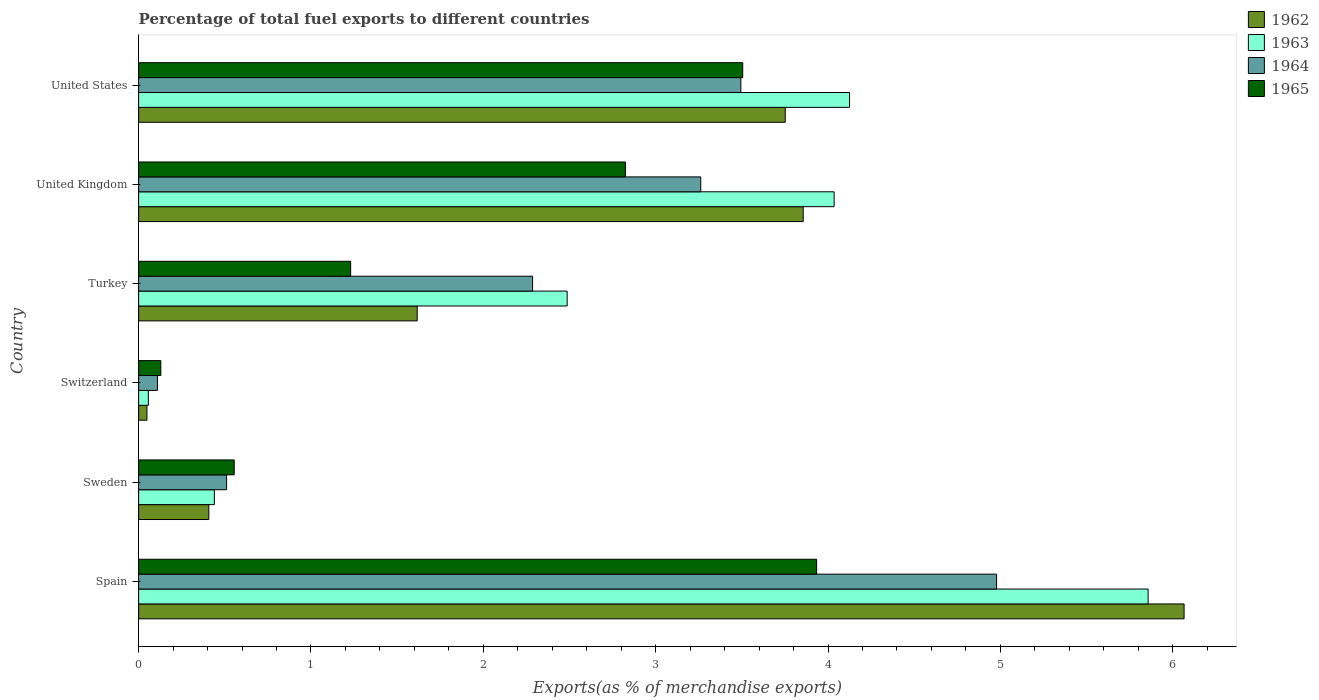Are the number of bars per tick equal to the number of legend labels?
Your answer should be very brief. Yes. How many bars are there on the 5th tick from the top?
Provide a succinct answer. 4. What is the label of the 6th group of bars from the top?
Offer a very short reply. Spain. What is the percentage of exports to different countries in 1963 in United States?
Ensure brevity in your answer.  4.13. Across all countries, what is the maximum percentage of exports to different countries in 1962?
Offer a terse response. 6.07. Across all countries, what is the minimum percentage of exports to different countries in 1962?
Offer a very short reply. 0.05. In which country was the percentage of exports to different countries in 1965 maximum?
Offer a terse response. Spain. In which country was the percentage of exports to different countries in 1962 minimum?
Offer a very short reply. Switzerland. What is the total percentage of exports to different countries in 1965 in the graph?
Your response must be concise. 12.18. What is the difference between the percentage of exports to different countries in 1963 in Sweden and that in Switzerland?
Offer a terse response. 0.38. What is the difference between the percentage of exports to different countries in 1964 in United States and the percentage of exports to different countries in 1965 in Turkey?
Ensure brevity in your answer.  2.26. What is the average percentage of exports to different countries in 1963 per country?
Your answer should be compact. 2.83. What is the difference between the percentage of exports to different countries in 1963 and percentage of exports to different countries in 1964 in Sweden?
Your response must be concise. -0.07. In how many countries, is the percentage of exports to different countries in 1965 greater than 1.6 %?
Give a very brief answer. 3. What is the ratio of the percentage of exports to different countries in 1963 in Spain to that in United States?
Ensure brevity in your answer.  1.42. Is the percentage of exports to different countries in 1965 in Switzerland less than that in United Kingdom?
Offer a terse response. Yes. Is the difference between the percentage of exports to different countries in 1963 in Turkey and United Kingdom greater than the difference between the percentage of exports to different countries in 1964 in Turkey and United Kingdom?
Your answer should be compact. No. What is the difference between the highest and the second highest percentage of exports to different countries in 1963?
Provide a short and direct response. 1.73. What is the difference between the highest and the lowest percentage of exports to different countries in 1963?
Make the answer very short. 5.8. Is it the case that in every country, the sum of the percentage of exports to different countries in 1963 and percentage of exports to different countries in 1962 is greater than the sum of percentage of exports to different countries in 1965 and percentage of exports to different countries in 1964?
Offer a very short reply. No. What does the 1st bar from the top in Turkey represents?
Provide a short and direct response. 1965. What does the 3rd bar from the bottom in Switzerland represents?
Provide a short and direct response. 1964. How many bars are there?
Keep it short and to the point. 24. Are all the bars in the graph horizontal?
Offer a terse response. Yes. How many countries are there in the graph?
Keep it short and to the point. 6. Does the graph contain any zero values?
Offer a very short reply. No. How many legend labels are there?
Provide a succinct answer. 4. What is the title of the graph?
Provide a succinct answer. Percentage of total fuel exports to different countries. What is the label or title of the X-axis?
Keep it short and to the point. Exports(as % of merchandise exports). What is the Exports(as % of merchandise exports) of 1962 in Spain?
Offer a terse response. 6.07. What is the Exports(as % of merchandise exports) of 1963 in Spain?
Provide a short and direct response. 5.86. What is the Exports(as % of merchandise exports) in 1964 in Spain?
Offer a terse response. 4.98. What is the Exports(as % of merchandise exports) of 1965 in Spain?
Provide a succinct answer. 3.93. What is the Exports(as % of merchandise exports) of 1962 in Sweden?
Your response must be concise. 0.41. What is the Exports(as % of merchandise exports) in 1963 in Sweden?
Ensure brevity in your answer.  0.44. What is the Exports(as % of merchandise exports) in 1964 in Sweden?
Provide a short and direct response. 0.51. What is the Exports(as % of merchandise exports) of 1965 in Sweden?
Ensure brevity in your answer.  0.55. What is the Exports(as % of merchandise exports) in 1962 in Switzerland?
Provide a short and direct response. 0.05. What is the Exports(as % of merchandise exports) of 1963 in Switzerland?
Offer a very short reply. 0.06. What is the Exports(as % of merchandise exports) in 1964 in Switzerland?
Your answer should be compact. 0.11. What is the Exports(as % of merchandise exports) of 1965 in Switzerland?
Keep it short and to the point. 0.13. What is the Exports(as % of merchandise exports) in 1962 in Turkey?
Your response must be concise. 1.62. What is the Exports(as % of merchandise exports) in 1963 in Turkey?
Offer a very short reply. 2.49. What is the Exports(as % of merchandise exports) of 1964 in Turkey?
Your response must be concise. 2.29. What is the Exports(as % of merchandise exports) of 1965 in Turkey?
Make the answer very short. 1.23. What is the Exports(as % of merchandise exports) in 1962 in United Kingdom?
Provide a short and direct response. 3.86. What is the Exports(as % of merchandise exports) of 1963 in United Kingdom?
Provide a short and direct response. 4.04. What is the Exports(as % of merchandise exports) in 1964 in United Kingdom?
Your response must be concise. 3.26. What is the Exports(as % of merchandise exports) of 1965 in United Kingdom?
Provide a short and direct response. 2.82. What is the Exports(as % of merchandise exports) in 1962 in United States?
Provide a short and direct response. 3.75. What is the Exports(as % of merchandise exports) in 1963 in United States?
Offer a terse response. 4.13. What is the Exports(as % of merchandise exports) in 1964 in United States?
Provide a succinct answer. 3.49. What is the Exports(as % of merchandise exports) of 1965 in United States?
Your answer should be compact. 3.51. Across all countries, what is the maximum Exports(as % of merchandise exports) of 1962?
Your answer should be compact. 6.07. Across all countries, what is the maximum Exports(as % of merchandise exports) in 1963?
Your answer should be very brief. 5.86. Across all countries, what is the maximum Exports(as % of merchandise exports) in 1964?
Offer a very short reply. 4.98. Across all countries, what is the maximum Exports(as % of merchandise exports) of 1965?
Offer a very short reply. 3.93. Across all countries, what is the minimum Exports(as % of merchandise exports) in 1962?
Your response must be concise. 0.05. Across all countries, what is the minimum Exports(as % of merchandise exports) in 1963?
Provide a succinct answer. 0.06. Across all countries, what is the minimum Exports(as % of merchandise exports) of 1964?
Make the answer very short. 0.11. Across all countries, what is the minimum Exports(as % of merchandise exports) in 1965?
Your answer should be very brief. 0.13. What is the total Exports(as % of merchandise exports) in 1962 in the graph?
Keep it short and to the point. 15.75. What is the total Exports(as % of merchandise exports) of 1963 in the graph?
Keep it short and to the point. 17. What is the total Exports(as % of merchandise exports) of 1964 in the graph?
Provide a succinct answer. 14.64. What is the total Exports(as % of merchandise exports) of 1965 in the graph?
Provide a succinct answer. 12.18. What is the difference between the Exports(as % of merchandise exports) of 1962 in Spain and that in Sweden?
Offer a terse response. 5.66. What is the difference between the Exports(as % of merchandise exports) in 1963 in Spain and that in Sweden?
Your response must be concise. 5.42. What is the difference between the Exports(as % of merchandise exports) in 1964 in Spain and that in Sweden?
Offer a very short reply. 4.47. What is the difference between the Exports(as % of merchandise exports) of 1965 in Spain and that in Sweden?
Ensure brevity in your answer.  3.38. What is the difference between the Exports(as % of merchandise exports) of 1962 in Spain and that in Switzerland?
Give a very brief answer. 6.02. What is the difference between the Exports(as % of merchandise exports) in 1963 in Spain and that in Switzerland?
Your response must be concise. 5.8. What is the difference between the Exports(as % of merchandise exports) of 1964 in Spain and that in Switzerland?
Provide a succinct answer. 4.87. What is the difference between the Exports(as % of merchandise exports) of 1965 in Spain and that in Switzerland?
Make the answer very short. 3.81. What is the difference between the Exports(as % of merchandise exports) of 1962 in Spain and that in Turkey?
Your answer should be compact. 4.45. What is the difference between the Exports(as % of merchandise exports) of 1963 in Spain and that in Turkey?
Give a very brief answer. 3.37. What is the difference between the Exports(as % of merchandise exports) of 1964 in Spain and that in Turkey?
Provide a short and direct response. 2.69. What is the difference between the Exports(as % of merchandise exports) of 1965 in Spain and that in Turkey?
Provide a short and direct response. 2.7. What is the difference between the Exports(as % of merchandise exports) of 1962 in Spain and that in United Kingdom?
Give a very brief answer. 2.21. What is the difference between the Exports(as % of merchandise exports) in 1963 in Spain and that in United Kingdom?
Make the answer very short. 1.82. What is the difference between the Exports(as % of merchandise exports) in 1964 in Spain and that in United Kingdom?
Keep it short and to the point. 1.72. What is the difference between the Exports(as % of merchandise exports) of 1965 in Spain and that in United Kingdom?
Provide a short and direct response. 1.11. What is the difference between the Exports(as % of merchandise exports) of 1962 in Spain and that in United States?
Keep it short and to the point. 2.31. What is the difference between the Exports(as % of merchandise exports) of 1963 in Spain and that in United States?
Your answer should be compact. 1.73. What is the difference between the Exports(as % of merchandise exports) of 1964 in Spain and that in United States?
Provide a succinct answer. 1.48. What is the difference between the Exports(as % of merchandise exports) of 1965 in Spain and that in United States?
Your response must be concise. 0.43. What is the difference between the Exports(as % of merchandise exports) of 1962 in Sweden and that in Switzerland?
Offer a very short reply. 0.36. What is the difference between the Exports(as % of merchandise exports) of 1963 in Sweden and that in Switzerland?
Provide a succinct answer. 0.38. What is the difference between the Exports(as % of merchandise exports) of 1964 in Sweden and that in Switzerland?
Give a very brief answer. 0.4. What is the difference between the Exports(as % of merchandise exports) in 1965 in Sweden and that in Switzerland?
Provide a short and direct response. 0.43. What is the difference between the Exports(as % of merchandise exports) of 1962 in Sweden and that in Turkey?
Your answer should be compact. -1.21. What is the difference between the Exports(as % of merchandise exports) in 1963 in Sweden and that in Turkey?
Make the answer very short. -2.05. What is the difference between the Exports(as % of merchandise exports) in 1964 in Sweden and that in Turkey?
Provide a short and direct response. -1.78. What is the difference between the Exports(as % of merchandise exports) in 1965 in Sweden and that in Turkey?
Keep it short and to the point. -0.68. What is the difference between the Exports(as % of merchandise exports) in 1962 in Sweden and that in United Kingdom?
Provide a short and direct response. -3.45. What is the difference between the Exports(as % of merchandise exports) in 1963 in Sweden and that in United Kingdom?
Your answer should be compact. -3.6. What is the difference between the Exports(as % of merchandise exports) in 1964 in Sweden and that in United Kingdom?
Your answer should be compact. -2.75. What is the difference between the Exports(as % of merchandise exports) in 1965 in Sweden and that in United Kingdom?
Make the answer very short. -2.27. What is the difference between the Exports(as % of merchandise exports) of 1962 in Sweden and that in United States?
Make the answer very short. -3.34. What is the difference between the Exports(as % of merchandise exports) in 1963 in Sweden and that in United States?
Give a very brief answer. -3.69. What is the difference between the Exports(as % of merchandise exports) in 1964 in Sweden and that in United States?
Provide a succinct answer. -2.98. What is the difference between the Exports(as % of merchandise exports) of 1965 in Sweden and that in United States?
Offer a very short reply. -2.95. What is the difference between the Exports(as % of merchandise exports) in 1962 in Switzerland and that in Turkey?
Provide a short and direct response. -1.57. What is the difference between the Exports(as % of merchandise exports) in 1963 in Switzerland and that in Turkey?
Ensure brevity in your answer.  -2.43. What is the difference between the Exports(as % of merchandise exports) in 1964 in Switzerland and that in Turkey?
Ensure brevity in your answer.  -2.18. What is the difference between the Exports(as % of merchandise exports) in 1965 in Switzerland and that in Turkey?
Ensure brevity in your answer.  -1.1. What is the difference between the Exports(as % of merchandise exports) of 1962 in Switzerland and that in United Kingdom?
Give a very brief answer. -3.81. What is the difference between the Exports(as % of merchandise exports) of 1963 in Switzerland and that in United Kingdom?
Your answer should be compact. -3.98. What is the difference between the Exports(as % of merchandise exports) in 1964 in Switzerland and that in United Kingdom?
Keep it short and to the point. -3.15. What is the difference between the Exports(as % of merchandise exports) of 1965 in Switzerland and that in United Kingdom?
Your answer should be very brief. -2.7. What is the difference between the Exports(as % of merchandise exports) of 1962 in Switzerland and that in United States?
Provide a short and direct response. -3.7. What is the difference between the Exports(as % of merchandise exports) of 1963 in Switzerland and that in United States?
Offer a very short reply. -4.07. What is the difference between the Exports(as % of merchandise exports) of 1964 in Switzerland and that in United States?
Offer a very short reply. -3.39. What is the difference between the Exports(as % of merchandise exports) of 1965 in Switzerland and that in United States?
Ensure brevity in your answer.  -3.38. What is the difference between the Exports(as % of merchandise exports) of 1962 in Turkey and that in United Kingdom?
Offer a very short reply. -2.24. What is the difference between the Exports(as % of merchandise exports) in 1963 in Turkey and that in United Kingdom?
Keep it short and to the point. -1.55. What is the difference between the Exports(as % of merchandise exports) in 1964 in Turkey and that in United Kingdom?
Provide a succinct answer. -0.98. What is the difference between the Exports(as % of merchandise exports) of 1965 in Turkey and that in United Kingdom?
Provide a succinct answer. -1.59. What is the difference between the Exports(as % of merchandise exports) of 1962 in Turkey and that in United States?
Keep it short and to the point. -2.14. What is the difference between the Exports(as % of merchandise exports) of 1963 in Turkey and that in United States?
Make the answer very short. -1.64. What is the difference between the Exports(as % of merchandise exports) in 1964 in Turkey and that in United States?
Give a very brief answer. -1.21. What is the difference between the Exports(as % of merchandise exports) of 1965 in Turkey and that in United States?
Your answer should be very brief. -2.27. What is the difference between the Exports(as % of merchandise exports) of 1962 in United Kingdom and that in United States?
Offer a terse response. 0.1. What is the difference between the Exports(as % of merchandise exports) of 1963 in United Kingdom and that in United States?
Your answer should be very brief. -0.09. What is the difference between the Exports(as % of merchandise exports) in 1964 in United Kingdom and that in United States?
Keep it short and to the point. -0.23. What is the difference between the Exports(as % of merchandise exports) of 1965 in United Kingdom and that in United States?
Provide a short and direct response. -0.68. What is the difference between the Exports(as % of merchandise exports) of 1962 in Spain and the Exports(as % of merchandise exports) of 1963 in Sweden?
Your answer should be compact. 5.63. What is the difference between the Exports(as % of merchandise exports) in 1962 in Spain and the Exports(as % of merchandise exports) in 1964 in Sweden?
Make the answer very short. 5.56. What is the difference between the Exports(as % of merchandise exports) in 1962 in Spain and the Exports(as % of merchandise exports) in 1965 in Sweden?
Offer a terse response. 5.51. What is the difference between the Exports(as % of merchandise exports) of 1963 in Spain and the Exports(as % of merchandise exports) of 1964 in Sweden?
Your answer should be very brief. 5.35. What is the difference between the Exports(as % of merchandise exports) in 1963 in Spain and the Exports(as % of merchandise exports) in 1965 in Sweden?
Provide a short and direct response. 5.3. What is the difference between the Exports(as % of merchandise exports) of 1964 in Spain and the Exports(as % of merchandise exports) of 1965 in Sweden?
Give a very brief answer. 4.42. What is the difference between the Exports(as % of merchandise exports) of 1962 in Spain and the Exports(as % of merchandise exports) of 1963 in Switzerland?
Provide a succinct answer. 6.01. What is the difference between the Exports(as % of merchandise exports) of 1962 in Spain and the Exports(as % of merchandise exports) of 1964 in Switzerland?
Keep it short and to the point. 5.96. What is the difference between the Exports(as % of merchandise exports) of 1962 in Spain and the Exports(as % of merchandise exports) of 1965 in Switzerland?
Provide a short and direct response. 5.94. What is the difference between the Exports(as % of merchandise exports) of 1963 in Spain and the Exports(as % of merchandise exports) of 1964 in Switzerland?
Provide a succinct answer. 5.75. What is the difference between the Exports(as % of merchandise exports) of 1963 in Spain and the Exports(as % of merchandise exports) of 1965 in Switzerland?
Provide a succinct answer. 5.73. What is the difference between the Exports(as % of merchandise exports) of 1964 in Spain and the Exports(as % of merchandise exports) of 1965 in Switzerland?
Offer a very short reply. 4.85. What is the difference between the Exports(as % of merchandise exports) in 1962 in Spain and the Exports(as % of merchandise exports) in 1963 in Turkey?
Offer a terse response. 3.58. What is the difference between the Exports(as % of merchandise exports) of 1962 in Spain and the Exports(as % of merchandise exports) of 1964 in Turkey?
Provide a short and direct response. 3.78. What is the difference between the Exports(as % of merchandise exports) in 1962 in Spain and the Exports(as % of merchandise exports) in 1965 in Turkey?
Give a very brief answer. 4.84. What is the difference between the Exports(as % of merchandise exports) of 1963 in Spain and the Exports(as % of merchandise exports) of 1964 in Turkey?
Give a very brief answer. 3.57. What is the difference between the Exports(as % of merchandise exports) of 1963 in Spain and the Exports(as % of merchandise exports) of 1965 in Turkey?
Offer a terse response. 4.63. What is the difference between the Exports(as % of merchandise exports) of 1964 in Spain and the Exports(as % of merchandise exports) of 1965 in Turkey?
Your answer should be compact. 3.75. What is the difference between the Exports(as % of merchandise exports) in 1962 in Spain and the Exports(as % of merchandise exports) in 1963 in United Kingdom?
Ensure brevity in your answer.  2.03. What is the difference between the Exports(as % of merchandise exports) in 1962 in Spain and the Exports(as % of merchandise exports) in 1964 in United Kingdom?
Keep it short and to the point. 2.8. What is the difference between the Exports(as % of merchandise exports) in 1962 in Spain and the Exports(as % of merchandise exports) in 1965 in United Kingdom?
Your response must be concise. 3.24. What is the difference between the Exports(as % of merchandise exports) in 1963 in Spain and the Exports(as % of merchandise exports) in 1964 in United Kingdom?
Offer a very short reply. 2.6. What is the difference between the Exports(as % of merchandise exports) in 1963 in Spain and the Exports(as % of merchandise exports) in 1965 in United Kingdom?
Offer a terse response. 3.03. What is the difference between the Exports(as % of merchandise exports) of 1964 in Spain and the Exports(as % of merchandise exports) of 1965 in United Kingdom?
Give a very brief answer. 2.15. What is the difference between the Exports(as % of merchandise exports) in 1962 in Spain and the Exports(as % of merchandise exports) in 1963 in United States?
Your response must be concise. 1.94. What is the difference between the Exports(as % of merchandise exports) of 1962 in Spain and the Exports(as % of merchandise exports) of 1964 in United States?
Your answer should be compact. 2.57. What is the difference between the Exports(as % of merchandise exports) in 1962 in Spain and the Exports(as % of merchandise exports) in 1965 in United States?
Give a very brief answer. 2.56. What is the difference between the Exports(as % of merchandise exports) in 1963 in Spain and the Exports(as % of merchandise exports) in 1964 in United States?
Offer a terse response. 2.36. What is the difference between the Exports(as % of merchandise exports) in 1963 in Spain and the Exports(as % of merchandise exports) in 1965 in United States?
Provide a short and direct response. 2.35. What is the difference between the Exports(as % of merchandise exports) of 1964 in Spain and the Exports(as % of merchandise exports) of 1965 in United States?
Ensure brevity in your answer.  1.47. What is the difference between the Exports(as % of merchandise exports) of 1962 in Sweden and the Exports(as % of merchandise exports) of 1963 in Switzerland?
Your answer should be very brief. 0.35. What is the difference between the Exports(as % of merchandise exports) in 1962 in Sweden and the Exports(as % of merchandise exports) in 1964 in Switzerland?
Your answer should be very brief. 0.3. What is the difference between the Exports(as % of merchandise exports) in 1962 in Sweden and the Exports(as % of merchandise exports) in 1965 in Switzerland?
Ensure brevity in your answer.  0.28. What is the difference between the Exports(as % of merchandise exports) in 1963 in Sweden and the Exports(as % of merchandise exports) in 1964 in Switzerland?
Your answer should be compact. 0.33. What is the difference between the Exports(as % of merchandise exports) of 1963 in Sweden and the Exports(as % of merchandise exports) of 1965 in Switzerland?
Your answer should be very brief. 0.31. What is the difference between the Exports(as % of merchandise exports) in 1964 in Sweden and the Exports(as % of merchandise exports) in 1965 in Switzerland?
Offer a terse response. 0.38. What is the difference between the Exports(as % of merchandise exports) of 1962 in Sweden and the Exports(as % of merchandise exports) of 1963 in Turkey?
Provide a short and direct response. -2.08. What is the difference between the Exports(as % of merchandise exports) in 1962 in Sweden and the Exports(as % of merchandise exports) in 1964 in Turkey?
Your response must be concise. -1.88. What is the difference between the Exports(as % of merchandise exports) in 1962 in Sweden and the Exports(as % of merchandise exports) in 1965 in Turkey?
Make the answer very short. -0.82. What is the difference between the Exports(as % of merchandise exports) of 1963 in Sweden and the Exports(as % of merchandise exports) of 1964 in Turkey?
Offer a terse response. -1.85. What is the difference between the Exports(as % of merchandise exports) in 1963 in Sweden and the Exports(as % of merchandise exports) in 1965 in Turkey?
Make the answer very short. -0.79. What is the difference between the Exports(as % of merchandise exports) of 1964 in Sweden and the Exports(as % of merchandise exports) of 1965 in Turkey?
Give a very brief answer. -0.72. What is the difference between the Exports(as % of merchandise exports) of 1962 in Sweden and the Exports(as % of merchandise exports) of 1963 in United Kingdom?
Offer a very short reply. -3.63. What is the difference between the Exports(as % of merchandise exports) of 1962 in Sweden and the Exports(as % of merchandise exports) of 1964 in United Kingdom?
Your answer should be very brief. -2.85. What is the difference between the Exports(as % of merchandise exports) in 1962 in Sweden and the Exports(as % of merchandise exports) in 1965 in United Kingdom?
Your answer should be compact. -2.42. What is the difference between the Exports(as % of merchandise exports) in 1963 in Sweden and the Exports(as % of merchandise exports) in 1964 in United Kingdom?
Provide a succinct answer. -2.82. What is the difference between the Exports(as % of merchandise exports) in 1963 in Sweden and the Exports(as % of merchandise exports) in 1965 in United Kingdom?
Make the answer very short. -2.38. What is the difference between the Exports(as % of merchandise exports) of 1964 in Sweden and the Exports(as % of merchandise exports) of 1965 in United Kingdom?
Provide a short and direct response. -2.31. What is the difference between the Exports(as % of merchandise exports) of 1962 in Sweden and the Exports(as % of merchandise exports) of 1963 in United States?
Your answer should be very brief. -3.72. What is the difference between the Exports(as % of merchandise exports) in 1962 in Sweden and the Exports(as % of merchandise exports) in 1964 in United States?
Ensure brevity in your answer.  -3.09. What is the difference between the Exports(as % of merchandise exports) of 1962 in Sweden and the Exports(as % of merchandise exports) of 1965 in United States?
Ensure brevity in your answer.  -3.1. What is the difference between the Exports(as % of merchandise exports) of 1963 in Sweden and the Exports(as % of merchandise exports) of 1964 in United States?
Make the answer very short. -3.05. What is the difference between the Exports(as % of merchandise exports) in 1963 in Sweden and the Exports(as % of merchandise exports) in 1965 in United States?
Offer a terse response. -3.07. What is the difference between the Exports(as % of merchandise exports) of 1964 in Sweden and the Exports(as % of merchandise exports) of 1965 in United States?
Give a very brief answer. -2.99. What is the difference between the Exports(as % of merchandise exports) in 1962 in Switzerland and the Exports(as % of merchandise exports) in 1963 in Turkey?
Ensure brevity in your answer.  -2.44. What is the difference between the Exports(as % of merchandise exports) in 1962 in Switzerland and the Exports(as % of merchandise exports) in 1964 in Turkey?
Your answer should be compact. -2.24. What is the difference between the Exports(as % of merchandise exports) of 1962 in Switzerland and the Exports(as % of merchandise exports) of 1965 in Turkey?
Your response must be concise. -1.18. What is the difference between the Exports(as % of merchandise exports) in 1963 in Switzerland and the Exports(as % of merchandise exports) in 1964 in Turkey?
Keep it short and to the point. -2.23. What is the difference between the Exports(as % of merchandise exports) in 1963 in Switzerland and the Exports(as % of merchandise exports) in 1965 in Turkey?
Offer a very short reply. -1.17. What is the difference between the Exports(as % of merchandise exports) of 1964 in Switzerland and the Exports(as % of merchandise exports) of 1965 in Turkey?
Keep it short and to the point. -1.12. What is the difference between the Exports(as % of merchandise exports) in 1962 in Switzerland and the Exports(as % of merchandise exports) in 1963 in United Kingdom?
Your response must be concise. -3.99. What is the difference between the Exports(as % of merchandise exports) of 1962 in Switzerland and the Exports(as % of merchandise exports) of 1964 in United Kingdom?
Your response must be concise. -3.21. What is the difference between the Exports(as % of merchandise exports) of 1962 in Switzerland and the Exports(as % of merchandise exports) of 1965 in United Kingdom?
Ensure brevity in your answer.  -2.78. What is the difference between the Exports(as % of merchandise exports) in 1963 in Switzerland and the Exports(as % of merchandise exports) in 1964 in United Kingdom?
Offer a terse response. -3.21. What is the difference between the Exports(as % of merchandise exports) in 1963 in Switzerland and the Exports(as % of merchandise exports) in 1965 in United Kingdom?
Make the answer very short. -2.77. What is the difference between the Exports(as % of merchandise exports) of 1964 in Switzerland and the Exports(as % of merchandise exports) of 1965 in United Kingdom?
Provide a succinct answer. -2.72. What is the difference between the Exports(as % of merchandise exports) in 1962 in Switzerland and the Exports(as % of merchandise exports) in 1963 in United States?
Provide a short and direct response. -4.08. What is the difference between the Exports(as % of merchandise exports) in 1962 in Switzerland and the Exports(as % of merchandise exports) in 1964 in United States?
Your response must be concise. -3.45. What is the difference between the Exports(as % of merchandise exports) in 1962 in Switzerland and the Exports(as % of merchandise exports) in 1965 in United States?
Provide a succinct answer. -3.46. What is the difference between the Exports(as % of merchandise exports) in 1963 in Switzerland and the Exports(as % of merchandise exports) in 1964 in United States?
Your answer should be compact. -3.44. What is the difference between the Exports(as % of merchandise exports) in 1963 in Switzerland and the Exports(as % of merchandise exports) in 1965 in United States?
Offer a terse response. -3.45. What is the difference between the Exports(as % of merchandise exports) in 1964 in Switzerland and the Exports(as % of merchandise exports) in 1965 in United States?
Your answer should be compact. -3.4. What is the difference between the Exports(as % of merchandise exports) in 1962 in Turkey and the Exports(as % of merchandise exports) in 1963 in United Kingdom?
Provide a succinct answer. -2.42. What is the difference between the Exports(as % of merchandise exports) of 1962 in Turkey and the Exports(as % of merchandise exports) of 1964 in United Kingdom?
Keep it short and to the point. -1.65. What is the difference between the Exports(as % of merchandise exports) in 1962 in Turkey and the Exports(as % of merchandise exports) in 1965 in United Kingdom?
Make the answer very short. -1.21. What is the difference between the Exports(as % of merchandise exports) of 1963 in Turkey and the Exports(as % of merchandise exports) of 1964 in United Kingdom?
Your response must be concise. -0.78. What is the difference between the Exports(as % of merchandise exports) in 1963 in Turkey and the Exports(as % of merchandise exports) in 1965 in United Kingdom?
Your answer should be compact. -0.34. What is the difference between the Exports(as % of merchandise exports) of 1964 in Turkey and the Exports(as % of merchandise exports) of 1965 in United Kingdom?
Your answer should be very brief. -0.54. What is the difference between the Exports(as % of merchandise exports) of 1962 in Turkey and the Exports(as % of merchandise exports) of 1963 in United States?
Your answer should be compact. -2.51. What is the difference between the Exports(as % of merchandise exports) of 1962 in Turkey and the Exports(as % of merchandise exports) of 1964 in United States?
Make the answer very short. -1.88. What is the difference between the Exports(as % of merchandise exports) of 1962 in Turkey and the Exports(as % of merchandise exports) of 1965 in United States?
Make the answer very short. -1.89. What is the difference between the Exports(as % of merchandise exports) in 1963 in Turkey and the Exports(as % of merchandise exports) in 1964 in United States?
Offer a very short reply. -1.01. What is the difference between the Exports(as % of merchandise exports) in 1963 in Turkey and the Exports(as % of merchandise exports) in 1965 in United States?
Provide a short and direct response. -1.02. What is the difference between the Exports(as % of merchandise exports) in 1964 in Turkey and the Exports(as % of merchandise exports) in 1965 in United States?
Ensure brevity in your answer.  -1.22. What is the difference between the Exports(as % of merchandise exports) in 1962 in United Kingdom and the Exports(as % of merchandise exports) in 1963 in United States?
Offer a very short reply. -0.27. What is the difference between the Exports(as % of merchandise exports) in 1962 in United Kingdom and the Exports(as % of merchandise exports) in 1964 in United States?
Offer a very short reply. 0.36. What is the difference between the Exports(as % of merchandise exports) of 1962 in United Kingdom and the Exports(as % of merchandise exports) of 1965 in United States?
Give a very brief answer. 0.35. What is the difference between the Exports(as % of merchandise exports) of 1963 in United Kingdom and the Exports(as % of merchandise exports) of 1964 in United States?
Give a very brief answer. 0.54. What is the difference between the Exports(as % of merchandise exports) of 1963 in United Kingdom and the Exports(as % of merchandise exports) of 1965 in United States?
Give a very brief answer. 0.53. What is the difference between the Exports(as % of merchandise exports) of 1964 in United Kingdom and the Exports(as % of merchandise exports) of 1965 in United States?
Provide a succinct answer. -0.24. What is the average Exports(as % of merchandise exports) of 1962 per country?
Your answer should be compact. 2.62. What is the average Exports(as % of merchandise exports) in 1963 per country?
Offer a very short reply. 2.83. What is the average Exports(as % of merchandise exports) of 1964 per country?
Ensure brevity in your answer.  2.44. What is the average Exports(as % of merchandise exports) in 1965 per country?
Offer a very short reply. 2.03. What is the difference between the Exports(as % of merchandise exports) in 1962 and Exports(as % of merchandise exports) in 1963 in Spain?
Offer a terse response. 0.21. What is the difference between the Exports(as % of merchandise exports) of 1962 and Exports(as % of merchandise exports) of 1964 in Spain?
Make the answer very short. 1.09. What is the difference between the Exports(as % of merchandise exports) of 1962 and Exports(as % of merchandise exports) of 1965 in Spain?
Ensure brevity in your answer.  2.13. What is the difference between the Exports(as % of merchandise exports) in 1963 and Exports(as % of merchandise exports) in 1964 in Spain?
Provide a short and direct response. 0.88. What is the difference between the Exports(as % of merchandise exports) of 1963 and Exports(as % of merchandise exports) of 1965 in Spain?
Make the answer very short. 1.92. What is the difference between the Exports(as % of merchandise exports) of 1964 and Exports(as % of merchandise exports) of 1965 in Spain?
Your response must be concise. 1.04. What is the difference between the Exports(as % of merchandise exports) in 1962 and Exports(as % of merchandise exports) in 1963 in Sweden?
Keep it short and to the point. -0.03. What is the difference between the Exports(as % of merchandise exports) in 1962 and Exports(as % of merchandise exports) in 1964 in Sweden?
Your answer should be very brief. -0.1. What is the difference between the Exports(as % of merchandise exports) of 1962 and Exports(as % of merchandise exports) of 1965 in Sweden?
Offer a terse response. -0.15. What is the difference between the Exports(as % of merchandise exports) in 1963 and Exports(as % of merchandise exports) in 1964 in Sweden?
Offer a very short reply. -0.07. What is the difference between the Exports(as % of merchandise exports) of 1963 and Exports(as % of merchandise exports) of 1965 in Sweden?
Provide a short and direct response. -0.12. What is the difference between the Exports(as % of merchandise exports) of 1964 and Exports(as % of merchandise exports) of 1965 in Sweden?
Provide a short and direct response. -0.04. What is the difference between the Exports(as % of merchandise exports) of 1962 and Exports(as % of merchandise exports) of 1963 in Switzerland?
Your response must be concise. -0.01. What is the difference between the Exports(as % of merchandise exports) of 1962 and Exports(as % of merchandise exports) of 1964 in Switzerland?
Your response must be concise. -0.06. What is the difference between the Exports(as % of merchandise exports) in 1962 and Exports(as % of merchandise exports) in 1965 in Switzerland?
Offer a terse response. -0.08. What is the difference between the Exports(as % of merchandise exports) in 1963 and Exports(as % of merchandise exports) in 1964 in Switzerland?
Your answer should be very brief. -0.05. What is the difference between the Exports(as % of merchandise exports) of 1963 and Exports(as % of merchandise exports) of 1965 in Switzerland?
Ensure brevity in your answer.  -0.07. What is the difference between the Exports(as % of merchandise exports) of 1964 and Exports(as % of merchandise exports) of 1965 in Switzerland?
Ensure brevity in your answer.  -0.02. What is the difference between the Exports(as % of merchandise exports) in 1962 and Exports(as % of merchandise exports) in 1963 in Turkey?
Your answer should be very brief. -0.87. What is the difference between the Exports(as % of merchandise exports) of 1962 and Exports(as % of merchandise exports) of 1964 in Turkey?
Your answer should be very brief. -0.67. What is the difference between the Exports(as % of merchandise exports) of 1962 and Exports(as % of merchandise exports) of 1965 in Turkey?
Provide a succinct answer. 0.39. What is the difference between the Exports(as % of merchandise exports) of 1963 and Exports(as % of merchandise exports) of 1964 in Turkey?
Make the answer very short. 0.2. What is the difference between the Exports(as % of merchandise exports) of 1963 and Exports(as % of merchandise exports) of 1965 in Turkey?
Offer a very short reply. 1.26. What is the difference between the Exports(as % of merchandise exports) in 1964 and Exports(as % of merchandise exports) in 1965 in Turkey?
Your answer should be very brief. 1.06. What is the difference between the Exports(as % of merchandise exports) in 1962 and Exports(as % of merchandise exports) in 1963 in United Kingdom?
Keep it short and to the point. -0.18. What is the difference between the Exports(as % of merchandise exports) of 1962 and Exports(as % of merchandise exports) of 1964 in United Kingdom?
Your answer should be compact. 0.59. What is the difference between the Exports(as % of merchandise exports) in 1962 and Exports(as % of merchandise exports) in 1965 in United Kingdom?
Give a very brief answer. 1.03. What is the difference between the Exports(as % of merchandise exports) in 1963 and Exports(as % of merchandise exports) in 1964 in United Kingdom?
Keep it short and to the point. 0.77. What is the difference between the Exports(as % of merchandise exports) in 1963 and Exports(as % of merchandise exports) in 1965 in United Kingdom?
Provide a succinct answer. 1.21. What is the difference between the Exports(as % of merchandise exports) of 1964 and Exports(as % of merchandise exports) of 1965 in United Kingdom?
Provide a short and direct response. 0.44. What is the difference between the Exports(as % of merchandise exports) in 1962 and Exports(as % of merchandise exports) in 1963 in United States?
Offer a very short reply. -0.37. What is the difference between the Exports(as % of merchandise exports) of 1962 and Exports(as % of merchandise exports) of 1964 in United States?
Your response must be concise. 0.26. What is the difference between the Exports(as % of merchandise exports) in 1962 and Exports(as % of merchandise exports) in 1965 in United States?
Keep it short and to the point. 0.25. What is the difference between the Exports(as % of merchandise exports) of 1963 and Exports(as % of merchandise exports) of 1964 in United States?
Keep it short and to the point. 0.63. What is the difference between the Exports(as % of merchandise exports) of 1963 and Exports(as % of merchandise exports) of 1965 in United States?
Your response must be concise. 0.62. What is the difference between the Exports(as % of merchandise exports) in 1964 and Exports(as % of merchandise exports) in 1965 in United States?
Provide a short and direct response. -0.01. What is the ratio of the Exports(as % of merchandise exports) in 1962 in Spain to that in Sweden?
Provide a short and direct response. 14.89. What is the ratio of the Exports(as % of merchandise exports) in 1963 in Spain to that in Sweden?
Provide a succinct answer. 13.33. What is the ratio of the Exports(as % of merchandise exports) in 1964 in Spain to that in Sweden?
Your answer should be compact. 9.75. What is the ratio of the Exports(as % of merchandise exports) in 1965 in Spain to that in Sweden?
Provide a short and direct response. 7.09. What is the ratio of the Exports(as % of merchandise exports) of 1962 in Spain to that in Switzerland?
Offer a very short reply. 125.74. What is the ratio of the Exports(as % of merchandise exports) in 1963 in Spain to that in Switzerland?
Give a very brief answer. 104.12. What is the ratio of the Exports(as % of merchandise exports) in 1964 in Spain to that in Switzerland?
Ensure brevity in your answer.  45.62. What is the ratio of the Exports(as % of merchandise exports) of 1965 in Spain to that in Switzerland?
Keep it short and to the point. 30.54. What is the ratio of the Exports(as % of merchandise exports) in 1962 in Spain to that in Turkey?
Make the answer very short. 3.75. What is the ratio of the Exports(as % of merchandise exports) in 1963 in Spain to that in Turkey?
Your response must be concise. 2.36. What is the ratio of the Exports(as % of merchandise exports) in 1964 in Spain to that in Turkey?
Ensure brevity in your answer.  2.18. What is the ratio of the Exports(as % of merchandise exports) of 1965 in Spain to that in Turkey?
Your response must be concise. 3.2. What is the ratio of the Exports(as % of merchandise exports) of 1962 in Spain to that in United Kingdom?
Make the answer very short. 1.57. What is the ratio of the Exports(as % of merchandise exports) of 1963 in Spain to that in United Kingdom?
Offer a terse response. 1.45. What is the ratio of the Exports(as % of merchandise exports) in 1964 in Spain to that in United Kingdom?
Keep it short and to the point. 1.53. What is the ratio of the Exports(as % of merchandise exports) in 1965 in Spain to that in United Kingdom?
Make the answer very short. 1.39. What is the ratio of the Exports(as % of merchandise exports) of 1962 in Spain to that in United States?
Offer a terse response. 1.62. What is the ratio of the Exports(as % of merchandise exports) of 1963 in Spain to that in United States?
Offer a very short reply. 1.42. What is the ratio of the Exports(as % of merchandise exports) in 1964 in Spain to that in United States?
Your answer should be very brief. 1.42. What is the ratio of the Exports(as % of merchandise exports) of 1965 in Spain to that in United States?
Your answer should be compact. 1.12. What is the ratio of the Exports(as % of merchandise exports) of 1962 in Sweden to that in Switzerland?
Your response must be concise. 8.44. What is the ratio of the Exports(as % of merchandise exports) in 1963 in Sweden to that in Switzerland?
Provide a succinct answer. 7.81. What is the ratio of the Exports(as % of merchandise exports) in 1964 in Sweden to that in Switzerland?
Your response must be concise. 4.68. What is the ratio of the Exports(as % of merchandise exports) in 1965 in Sweden to that in Switzerland?
Offer a terse response. 4.31. What is the ratio of the Exports(as % of merchandise exports) of 1962 in Sweden to that in Turkey?
Make the answer very short. 0.25. What is the ratio of the Exports(as % of merchandise exports) in 1963 in Sweden to that in Turkey?
Offer a very short reply. 0.18. What is the ratio of the Exports(as % of merchandise exports) in 1964 in Sweden to that in Turkey?
Keep it short and to the point. 0.22. What is the ratio of the Exports(as % of merchandise exports) in 1965 in Sweden to that in Turkey?
Provide a short and direct response. 0.45. What is the ratio of the Exports(as % of merchandise exports) in 1962 in Sweden to that in United Kingdom?
Make the answer very short. 0.11. What is the ratio of the Exports(as % of merchandise exports) of 1963 in Sweden to that in United Kingdom?
Ensure brevity in your answer.  0.11. What is the ratio of the Exports(as % of merchandise exports) in 1964 in Sweden to that in United Kingdom?
Offer a very short reply. 0.16. What is the ratio of the Exports(as % of merchandise exports) in 1965 in Sweden to that in United Kingdom?
Offer a very short reply. 0.2. What is the ratio of the Exports(as % of merchandise exports) of 1962 in Sweden to that in United States?
Ensure brevity in your answer.  0.11. What is the ratio of the Exports(as % of merchandise exports) of 1963 in Sweden to that in United States?
Ensure brevity in your answer.  0.11. What is the ratio of the Exports(as % of merchandise exports) in 1964 in Sweden to that in United States?
Your answer should be compact. 0.15. What is the ratio of the Exports(as % of merchandise exports) of 1965 in Sweden to that in United States?
Keep it short and to the point. 0.16. What is the ratio of the Exports(as % of merchandise exports) in 1962 in Switzerland to that in Turkey?
Offer a terse response. 0.03. What is the ratio of the Exports(as % of merchandise exports) of 1963 in Switzerland to that in Turkey?
Offer a very short reply. 0.02. What is the ratio of the Exports(as % of merchandise exports) of 1964 in Switzerland to that in Turkey?
Make the answer very short. 0.05. What is the ratio of the Exports(as % of merchandise exports) of 1965 in Switzerland to that in Turkey?
Keep it short and to the point. 0.1. What is the ratio of the Exports(as % of merchandise exports) of 1962 in Switzerland to that in United Kingdom?
Keep it short and to the point. 0.01. What is the ratio of the Exports(as % of merchandise exports) in 1963 in Switzerland to that in United Kingdom?
Ensure brevity in your answer.  0.01. What is the ratio of the Exports(as % of merchandise exports) in 1964 in Switzerland to that in United Kingdom?
Keep it short and to the point. 0.03. What is the ratio of the Exports(as % of merchandise exports) in 1965 in Switzerland to that in United Kingdom?
Your response must be concise. 0.05. What is the ratio of the Exports(as % of merchandise exports) of 1962 in Switzerland to that in United States?
Provide a succinct answer. 0.01. What is the ratio of the Exports(as % of merchandise exports) of 1963 in Switzerland to that in United States?
Provide a succinct answer. 0.01. What is the ratio of the Exports(as % of merchandise exports) of 1964 in Switzerland to that in United States?
Offer a terse response. 0.03. What is the ratio of the Exports(as % of merchandise exports) in 1965 in Switzerland to that in United States?
Your answer should be compact. 0.04. What is the ratio of the Exports(as % of merchandise exports) in 1962 in Turkey to that in United Kingdom?
Give a very brief answer. 0.42. What is the ratio of the Exports(as % of merchandise exports) of 1963 in Turkey to that in United Kingdom?
Give a very brief answer. 0.62. What is the ratio of the Exports(as % of merchandise exports) of 1964 in Turkey to that in United Kingdom?
Keep it short and to the point. 0.7. What is the ratio of the Exports(as % of merchandise exports) of 1965 in Turkey to that in United Kingdom?
Offer a terse response. 0.44. What is the ratio of the Exports(as % of merchandise exports) in 1962 in Turkey to that in United States?
Your response must be concise. 0.43. What is the ratio of the Exports(as % of merchandise exports) in 1963 in Turkey to that in United States?
Ensure brevity in your answer.  0.6. What is the ratio of the Exports(as % of merchandise exports) of 1964 in Turkey to that in United States?
Make the answer very short. 0.65. What is the ratio of the Exports(as % of merchandise exports) of 1965 in Turkey to that in United States?
Give a very brief answer. 0.35. What is the ratio of the Exports(as % of merchandise exports) of 1962 in United Kingdom to that in United States?
Offer a very short reply. 1.03. What is the ratio of the Exports(as % of merchandise exports) in 1963 in United Kingdom to that in United States?
Make the answer very short. 0.98. What is the ratio of the Exports(as % of merchandise exports) in 1964 in United Kingdom to that in United States?
Give a very brief answer. 0.93. What is the ratio of the Exports(as % of merchandise exports) in 1965 in United Kingdom to that in United States?
Keep it short and to the point. 0.81. What is the difference between the highest and the second highest Exports(as % of merchandise exports) in 1962?
Offer a terse response. 2.21. What is the difference between the highest and the second highest Exports(as % of merchandise exports) in 1963?
Your answer should be compact. 1.73. What is the difference between the highest and the second highest Exports(as % of merchandise exports) in 1964?
Offer a very short reply. 1.48. What is the difference between the highest and the second highest Exports(as % of merchandise exports) in 1965?
Give a very brief answer. 0.43. What is the difference between the highest and the lowest Exports(as % of merchandise exports) of 1962?
Your response must be concise. 6.02. What is the difference between the highest and the lowest Exports(as % of merchandise exports) in 1963?
Keep it short and to the point. 5.8. What is the difference between the highest and the lowest Exports(as % of merchandise exports) of 1964?
Your answer should be compact. 4.87. What is the difference between the highest and the lowest Exports(as % of merchandise exports) of 1965?
Your answer should be compact. 3.81. 